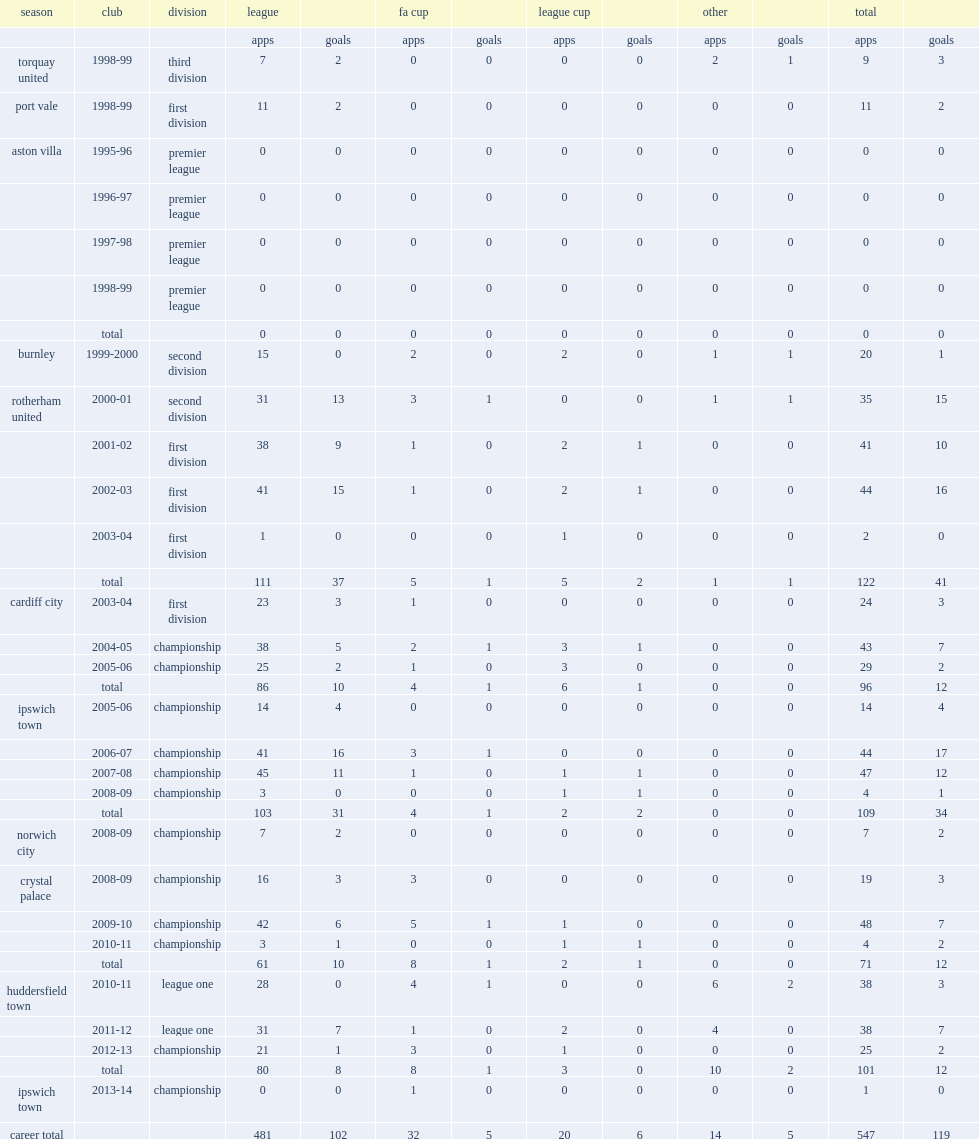How many goals did alan lee score in his career? 119.0. 